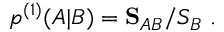<formula> <loc_0><loc_0><loc_500><loc_500>\begin{array} { r } { p ^ { ( 1 ) } ( A | B ) = S _ { A B } / S _ { B } \ . } \end{array}</formula> 